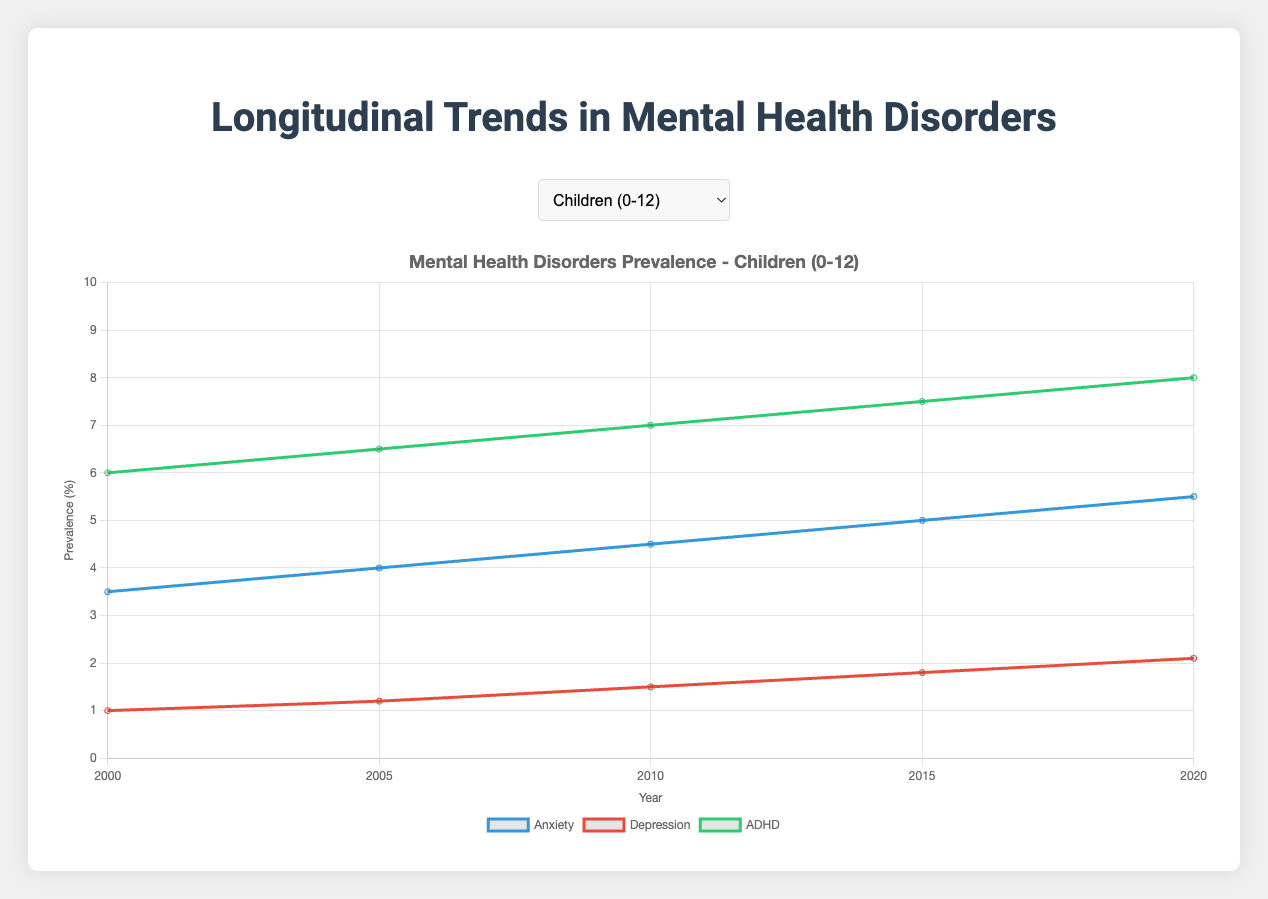Which age group shows the highest increase in Anxiety prevalence from 2000 to 2020? To find the highest increase, we need to calculate the difference between the 2020 and 2000 values for each age group. Children: (5.5 - 3.5 = 2.0), Adolescents: (7.5 - 5.0 = 2.5), Young Adults: (8.5 - 6.0 = 2.5), Adults: (9.0 - 7.0 = 2.0), Seniors: (5.0 - 4.0 = 1.0). The highest increase is in Adolescents and Young Adults, both by 2.5%.
Answer: Adolescents and Young Adults How does the prevalence of Depression in Young Adults in 2020 compare to Depression in Adults in 2005? We look for Depression percentage in Young Adults in 2020 and Adults in 2005. Young Adults in 2020: 7.8, Adults in 2005: 6.5. 7.8 is greater than 6.5.
Answer: Higher in Young Adults 2020 What is the trend of ADHD in Children from 2000 to 2020? Observe the data points for ADHD in Children: (6.0, 6.5, 7.0, 7.5, 8.0). The trend is increasing over the years.
Answer: Increasing Which mental health disorder among Seniors shows the greatest increase in prevalence from 2000 to 2020? Calculate the difference from 2020 to 2000 for each disorder in Seniors. Anxiety: (5.0 - 4.0 = 1.0), Depression: (4.5 - 3.5 = 1.0), Dementia: (7.0 - 5.0 = 2.0). Dementia shows the greatest increase.
Answer: Dementia Which age group exhibits the lowest prevalence of any mental health disorder in 2020? Check the lowest value for each disorder in 2020 across all age groups. Children (Anxiety: 5.5, Depression: 2.1, ADHD: 8.0), Adolescents (Anxiety: 7.5, Depression: 6.7, ADHD: 8.0), Young Adults (Anxiety: 8.5, Depression: 7.8, Bipolar: 2.0), Adults (Anxiety: 9.0, Depression: 8.1, Bipolar: 2.5), Seniors (Anxiety: 5.0, Depression: 4.5, Dementia: 7.0). The lowest is Depression in Children 2.1.
Answer: Children What is the average prevalence of Anxiety in Adults over the given years? Add up all the percentages for Anxiety in Adults and divide by the number of years: (7.0 + 7.5 + 8.0 + 8.5 + 9.0) / 5 = 40.0 / 5 = 8.0.
Answer: 8.0 What is the difference in prevalence of Bipolar Disorder between Young Adults and Adults in the year 2010? Look at the Bipolar Disorder values for both groups in 2010: Young Adults: 1.7, Adults: 2.3. Difference is 2.3 - 1.7 = 0.6.
Answer: 0.6 Which mental health disorder in Adolescents showed the smallest change from 2000 to 2020? Calculate the difference for each disorder in Adolescents from 2020 to 2000. Anxiety: (7.5 - 5.0 = 2.5), Depression: (6.7 - 4.5 = 2.2), ADHD: (8.0 - 7.0 = 1.0). ADHD shows the smallest change.
Answer: ADHD What is the median prevalence of Depression in Seniors over the surveyed years? List the values for Depression in Seniors (3.5, 3.7, 4.0, 4.2, 4.5), the median is the middle value in the ordered list, which is 4.0.
Answer: 4.0 How do the 2020 prevalence values of Dementia and Depression in Seniors compare? Look at the prevalence values in 2020 for Seniors: Dementia: 7.0, Depression: 4.5. Dementia is higher than Depression.
Answer: Dementia is higher 